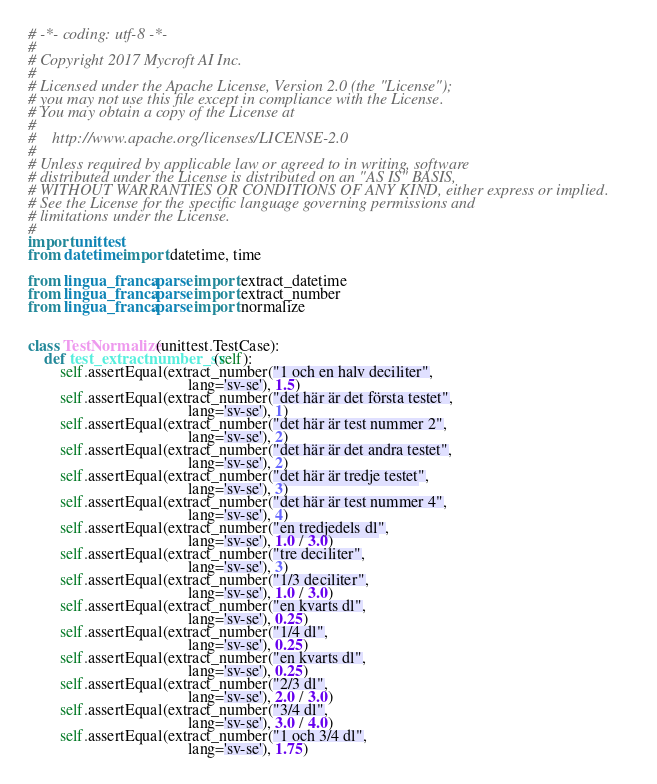<code> <loc_0><loc_0><loc_500><loc_500><_Python_># -*- coding: utf-8 -*-
#
# Copyright 2017 Mycroft AI Inc.
#
# Licensed under the Apache License, Version 2.0 (the "License");
# you may not use this file except in compliance with the License.
# You may obtain a copy of the License at
#
#    http://www.apache.org/licenses/LICENSE-2.0
#
# Unless required by applicable law or agreed to in writing, software
# distributed under the License is distributed on an "AS IS" BASIS,
# WITHOUT WARRANTIES OR CONDITIONS OF ANY KIND, either express or implied.
# See the License for the specific language governing permissions and
# limitations under the License.
#
import unittest
from datetime import datetime, time

from lingua_franca.parse import extract_datetime
from lingua_franca.parse import extract_number
from lingua_franca.parse import normalize


class TestNormalize(unittest.TestCase):
    def test_extractnumber_sv(self):
        self.assertEqual(extract_number("1 och en halv deciliter",
                                        lang='sv-se'), 1.5)
        self.assertEqual(extract_number("det här är det första testet",
                                        lang='sv-se'), 1)
        self.assertEqual(extract_number("det här är test nummer 2",
                                        lang='sv-se'), 2)
        self.assertEqual(extract_number("det här är det andra testet",
                                        lang='sv-se'), 2)
        self.assertEqual(extract_number("det här är tredje testet",
                                        lang='sv-se'), 3)
        self.assertEqual(extract_number("det här är test nummer 4",
                                        lang='sv-se'), 4)
        self.assertEqual(extract_number("en tredjedels dl",
                                        lang='sv-se'), 1.0 / 3.0)
        self.assertEqual(extract_number("tre deciliter",
                                        lang='sv-se'), 3)
        self.assertEqual(extract_number("1/3 deciliter",
                                        lang='sv-se'), 1.0 / 3.0)
        self.assertEqual(extract_number("en kvarts dl",
                                        lang='sv-se'), 0.25)
        self.assertEqual(extract_number("1/4 dl",
                                        lang='sv-se'), 0.25)
        self.assertEqual(extract_number("en kvarts dl",
                                        lang='sv-se'), 0.25)
        self.assertEqual(extract_number("2/3 dl",
                                        lang='sv-se'), 2.0 / 3.0)
        self.assertEqual(extract_number("3/4 dl",
                                        lang='sv-se'), 3.0 / 4.0)
        self.assertEqual(extract_number("1 och 3/4 dl",
                                        lang='sv-se'), 1.75)</code> 